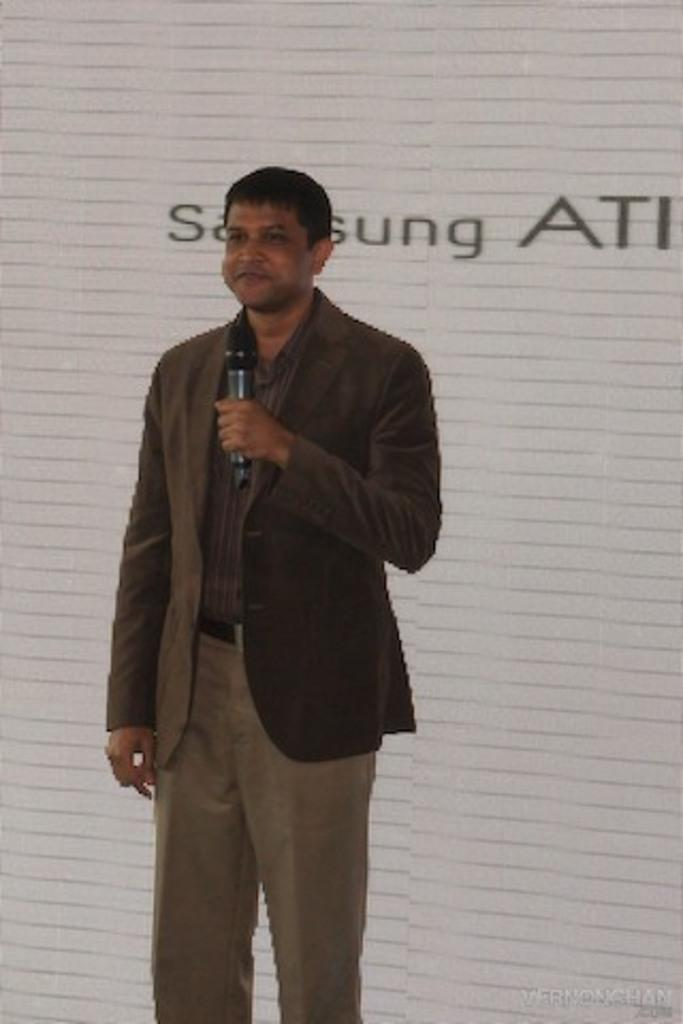What is the main subject of the image? There is a person standing in the center of the image. What is the person holding in the image? The person is holding a microphone. What is the person's facial expression in the image? The person is smiling. What can be seen in the background of the image? There is a wall and a banner in the background of the image. Can you tell me how many geese are depicted on the banner in the image? There are no geese depicted on the banner or anywhere else in the image. What type of alarm is present in the image? There is no alarm present in the image. 